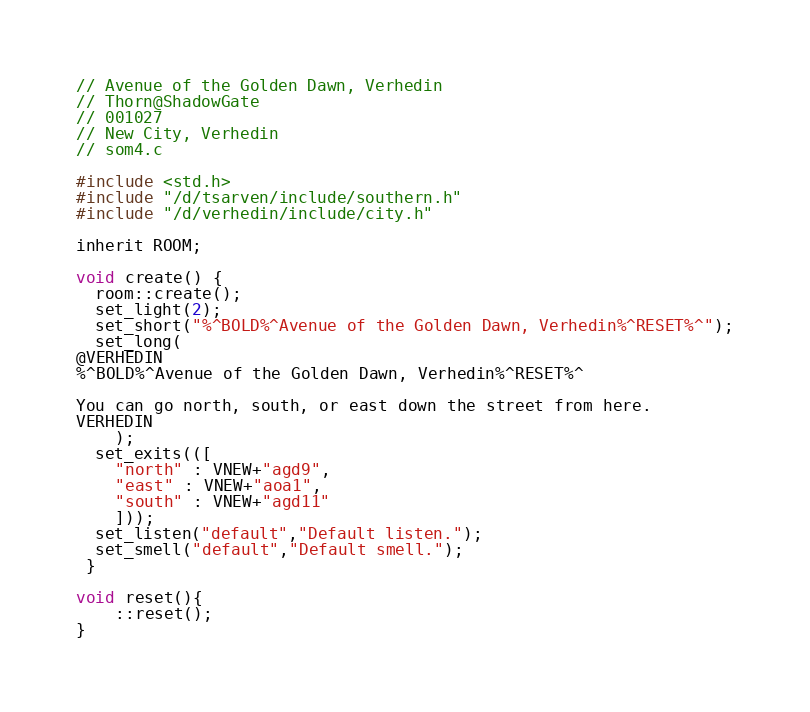Convert code to text. <code><loc_0><loc_0><loc_500><loc_500><_C_>
// Avenue of the Golden Dawn, Verhedin
// Thorn@ShadowGate
// 001027
// New City, Verhedin
// som4.c

#include <std.h>
#include "/d/tsarven/include/southern.h"
#include "/d/verhedin/include/city.h"

inherit ROOM;

void create() {
  room::create();
  set_light(2);
  set_short("%^BOLD%^Avenue of the Golden Dawn, Verhedin%^RESET%^");
  set_long(
@VERHEDIN
%^BOLD%^Avenue of the Golden Dawn, Verhedin%^RESET%^

You can go north, south, or east down the street from here.
VERHEDIN
    );
  set_exits(([
    "north" : VNEW+"agd9",
    "east" : VNEW+"aoa1",
    "south" : VNEW+"agd11"
    ]));
  set_listen("default","Default listen.");
  set_smell("default","Default smell.");
 }

void reset(){
	::reset();
}
</code> 